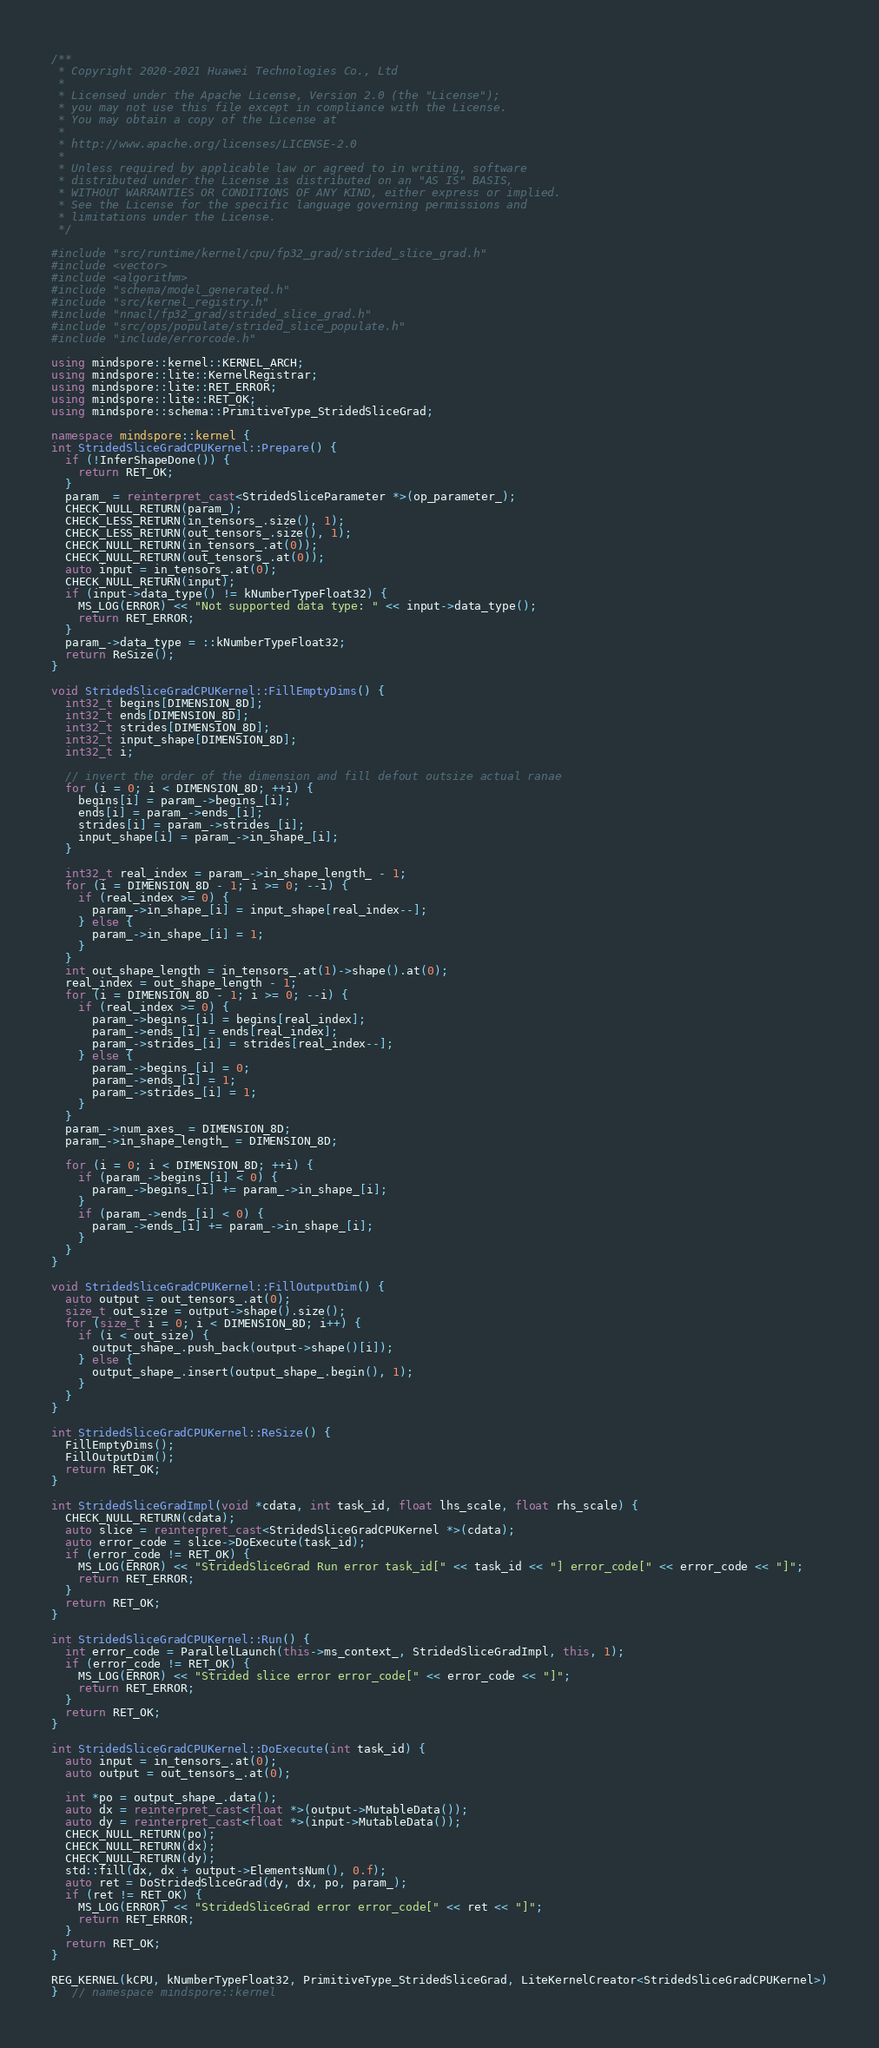<code> <loc_0><loc_0><loc_500><loc_500><_C++_>
/**
 * Copyright 2020-2021 Huawei Technologies Co., Ltd
 *
 * Licensed under the Apache License, Version 2.0 (the "License");
 * you may not use this file except in compliance with the License.
 * You may obtain a copy of the License at
 *
 * http://www.apache.org/licenses/LICENSE-2.0
 *
 * Unless required by applicable law or agreed to in writing, software
 * distributed under the License is distributed on an "AS IS" BASIS,
 * WITHOUT WARRANTIES OR CONDITIONS OF ANY KIND, either express or implied.
 * See the License for the specific language governing permissions and
 * limitations under the License.
 */

#include "src/runtime/kernel/cpu/fp32_grad/strided_slice_grad.h"
#include <vector>
#include <algorithm>
#include "schema/model_generated.h"
#include "src/kernel_registry.h"
#include "nnacl/fp32_grad/strided_slice_grad.h"
#include "src/ops/populate/strided_slice_populate.h"
#include "include/errorcode.h"

using mindspore::kernel::KERNEL_ARCH;
using mindspore::lite::KernelRegistrar;
using mindspore::lite::RET_ERROR;
using mindspore::lite::RET_OK;
using mindspore::schema::PrimitiveType_StridedSliceGrad;

namespace mindspore::kernel {
int StridedSliceGradCPUKernel::Prepare() {
  if (!InferShapeDone()) {
    return RET_OK;
  }
  param_ = reinterpret_cast<StridedSliceParameter *>(op_parameter_);
  CHECK_NULL_RETURN(param_);
  CHECK_LESS_RETURN(in_tensors_.size(), 1);
  CHECK_LESS_RETURN(out_tensors_.size(), 1);
  CHECK_NULL_RETURN(in_tensors_.at(0));
  CHECK_NULL_RETURN(out_tensors_.at(0));
  auto input = in_tensors_.at(0);
  CHECK_NULL_RETURN(input);
  if (input->data_type() != kNumberTypeFloat32) {
    MS_LOG(ERROR) << "Not supported data type: " << input->data_type();
    return RET_ERROR;
  }
  param_->data_type = ::kNumberTypeFloat32;
  return ReSize();
}

void StridedSliceGradCPUKernel::FillEmptyDims() {
  int32_t begins[DIMENSION_8D];
  int32_t ends[DIMENSION_8D];
  int32_t strides[DIMENSION_8D];
  int32_t input_shape[DIMENSION_8D];
  int32_t i;

  // invert the order of the dimension and fill defout outsize actual ranae
  for (i = 0; i < DIMENSION_8D; ++i) {
    begins[i] = param_->begins_[i];
    ends[i] = param_->ends_[i];
    strides[i] = param_->strides_[i];
    input_shape[i] = param_->in_shape_[i];
  }

  int32_t real_index = param_->in_shape_length_ - 1;
  for (i = DIMENSION_8D - 1; i >= 0; --i) {
    if (real_index >= 0) {
      param_->in_shape_[i] = input_shape[real_index--];
    } else {
      param_->in_shape_[i] = 1;
    }
  }
  int out_shape_length = in_tensors_.at(1)->shape().at(0);
  real_index = out_shape_length - 1;
  for (i = DIMENSION_8D - 1; i >= 0; --i) {
    if (real_index >= 0) {
      param_->begins_[i] = begins[real_index];
      param_->ends_[i] = ends[real_index];
      param_->strides_[i] = strides[real_index--];
    } else {
      param_->begins_[i] = 0;
      param_->ends_[i] = 1;
      param_->strides_[i] = 1;
    }
  }
  param_->num_axes_ = DIMENSION_8D;
  param_->in_shape_length_ = DIMENSION_8D;

  for (i = 0; i < DIMENSION_8D; ++i) {
    if (param_->begins_[i] < 0) {
      param_->begins_[i] += param_->in_shape_[i];
    }
    if (param_->ends_[i] < 0) {
      param_->ends_[i] += param_->in_shape_[i];
    }
  }
}

void StridedSliceGradCPUKernel::FillOutputDim() {
  auto output = out_tensors_.at(0);
  size_t out_size = output->shape().size();
  for (size_t i = 0; i < DIMENSION_8D; i++) {
    if (i < out_size) {
      output_shape_.push_back(output->shape()[i]);
    } else {
      output_shape_.insert(output_shape_.begin(), 1);
    }
  }
}

int StridedSliceGradCPUKernel::ReSize() {
  FillEmptyDims();
  FillOutputDim();
  return RET_OK;
}

int StridedSliceGradImpl(void *cdata, int task_id, float lhs_scale, float rhs_scale) {
  CHECK_NULL_RETURN(cdata);
  auto slice = reinterpret_cast<StridedSliceGradCPUKernel *>(cdata);
  auto error_code = slice->DoExecute(task_id);
  if (error_code != RET_OK) {
    MS_LOG(ERROR) << "StridedSliceGrad Run error task_id[" << task_id << "] error_code[" << error_code << "]";
    return RET_ERROR;
  }
  return RET_OK;
}

int StridedSliceGradCPUKernel::Run() {
  int error_code = ParallelLaunch(this->ms_context_, StridedSliceGradImpl, this, 1);
  if (error_code != RET_OK) {
    MS_LOG(ERROR) << "Strided slice error error_code[" << error_code << "]";
    return RET_ERROR;
  }
  return RET_OK;
}

int StridedSliceGradCPUKernel::DoExecute(int task_id) {
  auto input = in_tensors_.at(0);
  auto output = out_tensors_.at(0);

  int *po = output_shape_.data();
  auto dx = reinterpret_cast<float *>(output->MutableData());
  auto dy = reinterpret_cast<float *>(input->MutableData());
  CHECK_NULL_RETURN(po);
  CHECK_NULL_RETURN(dx);
  CHECK_NULL_RETURN(dy);
  std::fill(dx, dx + output->ElementsNum(), 0.f);
  auto ret = DoStridedSliceGrad(dy, dx, po, param_);
  if (ret != RET_OK) {
    MS_LOG(ERROR) << "StridedSliceGrad error error_code[" << ret << "]";
    return RET_ERROR;
  }
  return RET_OK;
}

REG_KERNEL(kCPU, kNumberTypeFloat32, PrimitiveType_StridedSliceGrad, LiteKernelCreator<StridedSliceGradCPUKernel>)
}  // namespace mindspore::kernel
</code> 